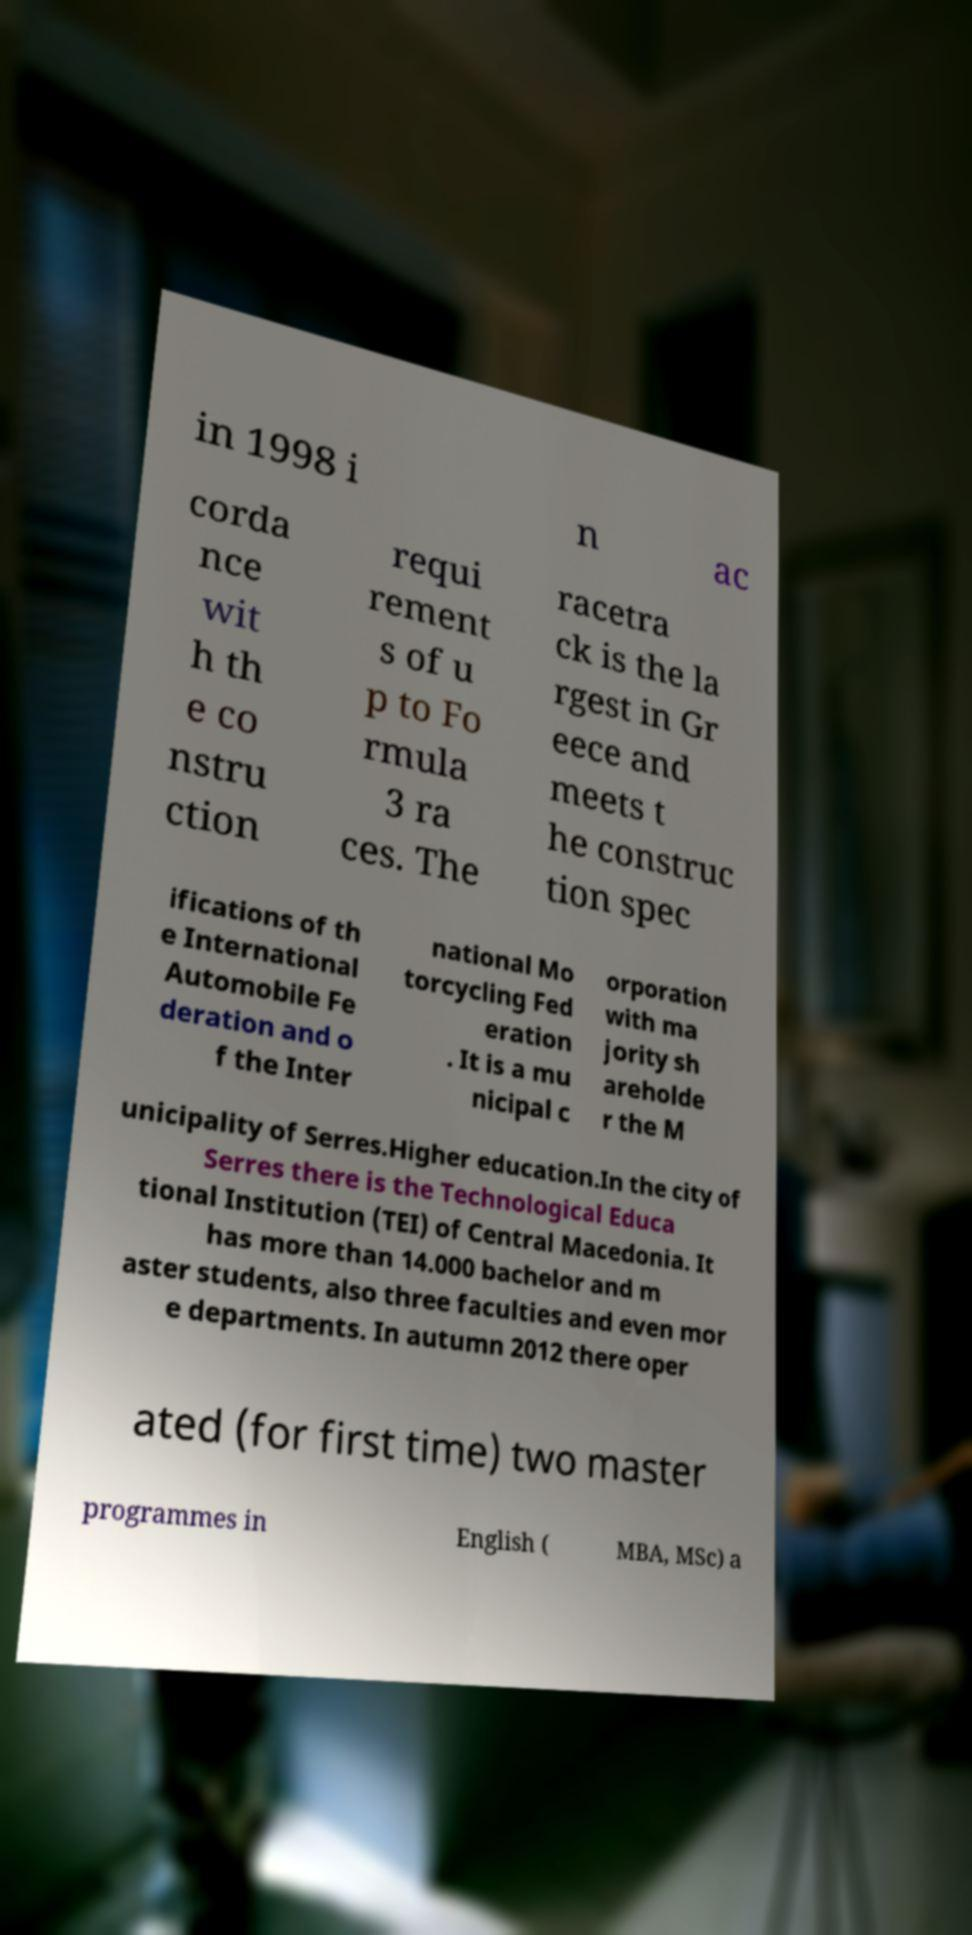Could you extract and type out the text from this image? in 1998 i n ac corda nce wit h th e co nstru ction requi rement s of u p to Fo rmula 3 ra ces. The racetra ck is the la rgest in Gr eece and meets t he construc tion spec ifications of th e International Automobile Fe deration and o f the Inter national Mo torcycling Fed eration . It is a mu nicipal c orporation with ma jority sh areholde r the M unicipality of Serres.Higher education.In the city of Serres there is the Technological Educa tional Institution (TEI) of Central Macedonia. It has more than 14.000 bachelor and m aster students, also three faculties and even mor e departments. In autumn 2012 there oper ated (for first time) two master programmes in English ( MBA, MSc) a 